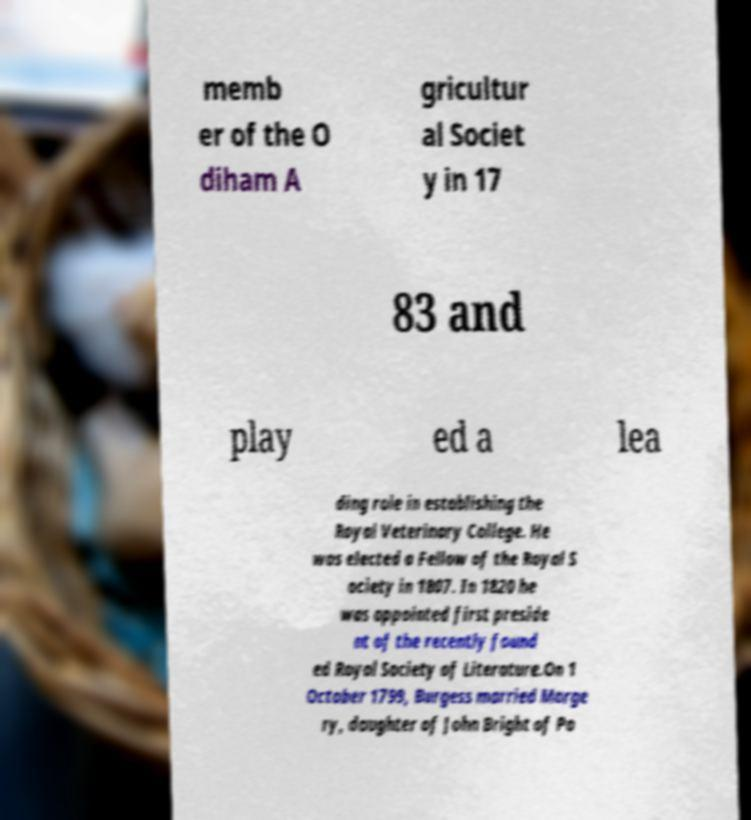There's text embedded in this image that I need extracted. Can you transcribe it verbatim? memb er of the O diham A gricultur al Societ y in 17 83 and play ed a lea ding role in establishing the Royal Veterinary College. He was elected a Fellow of the Royal S ociety in 1807. In 1820 he was appointed first preside nt of the recently found ed Royal Society of Literature.On 1 October 1799, Burgess married Marge ry, daughter of John Bright of Po 